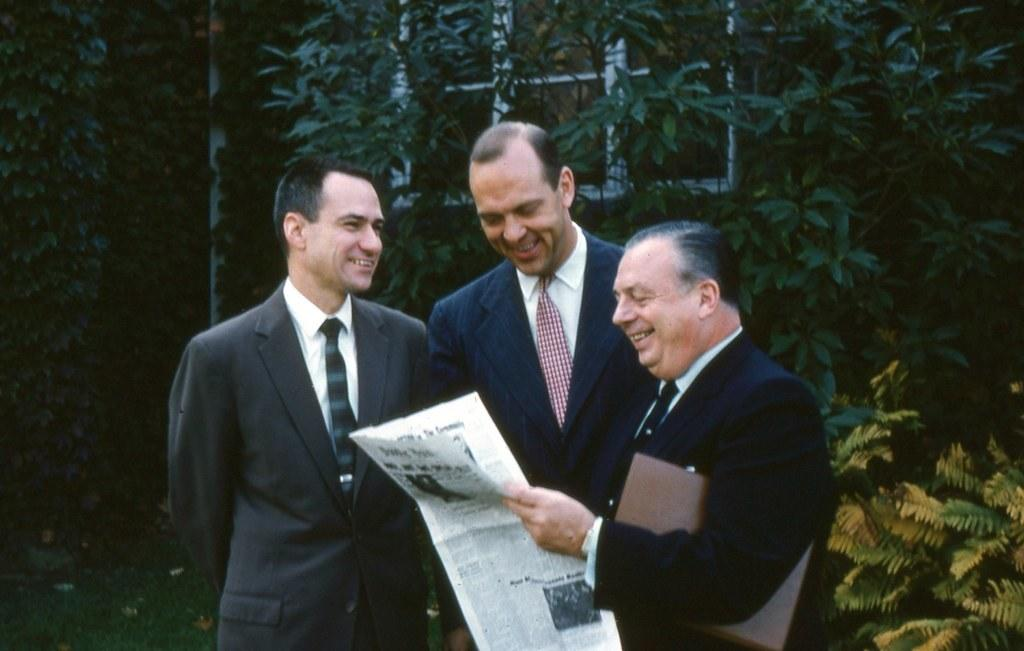What can be observed about the people in the image? There are people standing in the image, and they are wearing coats and ties. What are the people holding in the image? One person is holding a paper, and another person is holding a file. What can be seen in the background of the image? There are trees in the background of the image. What type of plough is being used in the image? There is no plough present in the image. What color is the sky in the image? The provided facts do not mention the color of the sky, so we cannot determine its color from the image. 